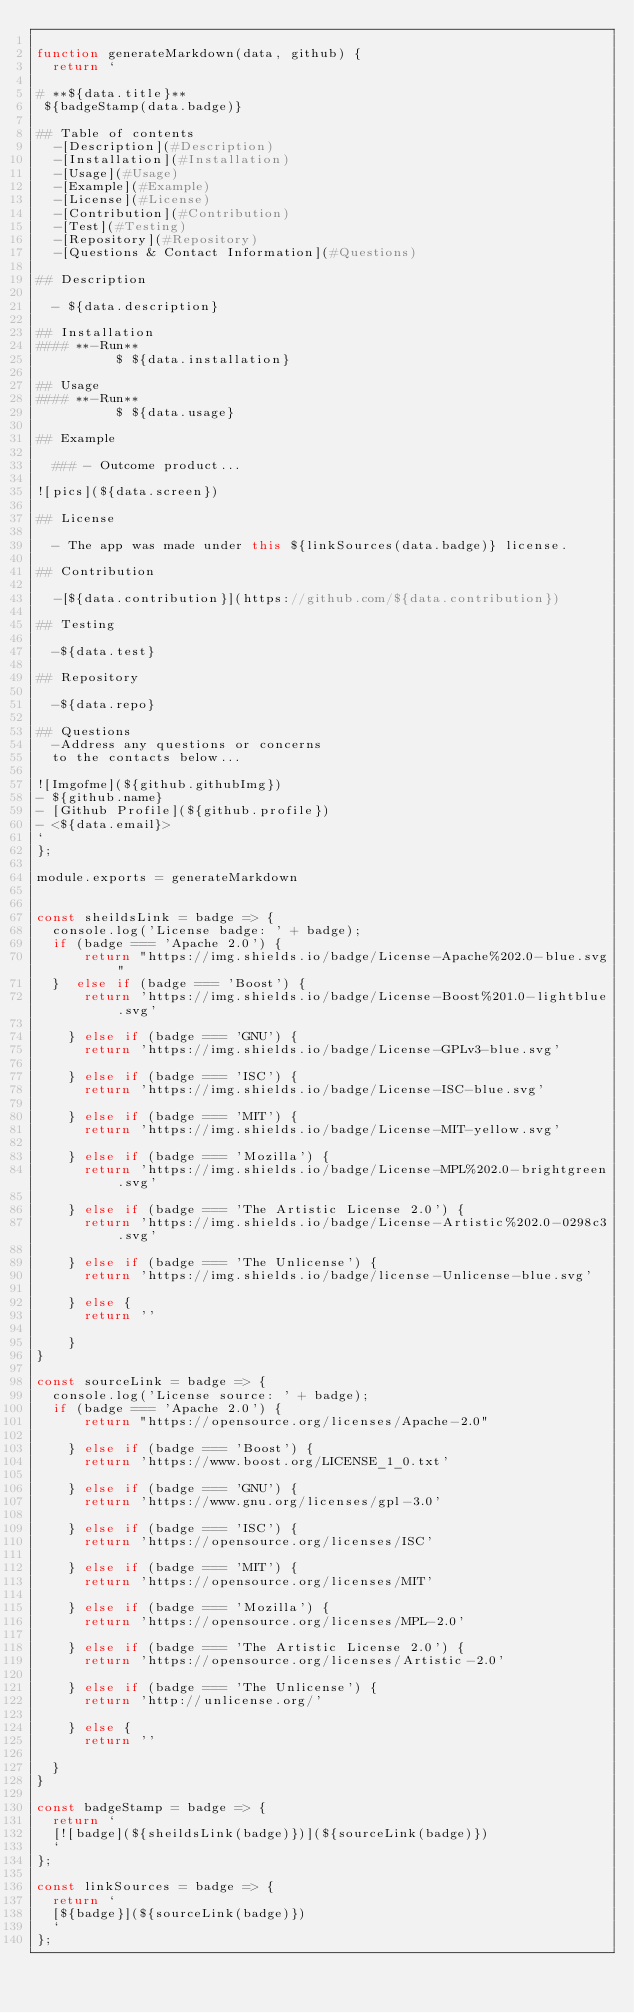Convert code to text. <code><loc_0><loc_0><loc_500><loc_500><_JavaScript_>
function generateMarkdown(data, github) {
  return `

# **${data.title}**
 ${badgeStamp(data.badge)}

## Table of contents
  -[Description](#Description)
  -[Installation](#Installation)
  -[Usage](#Usage)
  -[Example](#Example)
  -[License](#License)
  -[Contribution](#Contribution)
  -[Test](#Testing)
  -[Repository](#Repository)
  -[Questions & Contact Information](#Questions)

## Description

  - ${data.description}

## Installation
#### **-Run**
          $ ${data.installation}
    
## Usage
#### **-Run**
          $ ${data.usage}

## Example 

  ### - Outcome product...

![pics](${data.screen})

## License

  - The app was made under this ${linkSources(data.badge)} license.

## Contribution

  -[${data.contribution}](https://github.com/${data.contribution})

## Testing 
  
  -${data.test}

## Repository

  -${data.repo}

## Questions
  -Address any questions or concerns 
  to the contacts below...
                
![Imgofme](${github.githubImg})
- ${github.name}
- [Github Profile](${github.profile})
- <${data.email}>
`
};

module.exports = generateMarkdown


const sheildsLink = badge => {
  console.log('License badge: ' + badge);
  if (badge === 'Apache 2.0') {
      return "https://img.shields.io/badge/License-Apache%202.0-blue.svg"
  }  else if (badge === 'Boost') {
      return 'https://img.shields.io/badge/License-Boost%201.0-lightblue.svg'
  
    } else if (badge === 'GNU') {
      return 'https://img.shields.io/badge/License-GPLv3-blue.svg'
  
    } else if (badge === 'ISC') {
      return 'https://img.shields.io/badge/License-ISC-blue.svg'
  
    } else if (badge === 'MIT') {
      return 'https://img.shields.io/badge/License-MIT-yellow.svg'
  
    } else if (badge === 'Mozilla') {
      return 'https://img.shields.io/badge/License-MPL%202.0-brightgreen.svg'
  
    } else if (badge === 'The Artistic License 2.0') {
      return 'https://img.shields.io/badge/License-Artistic%202.0-0298c3.svg'
  
    } else if (badge === 'The Unlicense') {
      return 'https://img.shields.io/badge/license-Unlicense-blue.svg'
  
    } else {
      return ''

    }
}

const sourceLink = badge => {
  console.log('License source: ' + badge);
  if (badge === 'Apache 2.0') {
      return "https://opensource.org/licenses/Apache-2.0"
  
    } else if (badge === 'Boost') {
      return 'https://www.boost.org/LICENSE_1_0.txt'
  
    } else if (badge === 'GNU') {
      return 'https://www.gnu.org/licenses/gpl-3.0'
  
    } else if (badge === 'ISC') {
      return 'https://opensource.org/licenses/ISC'
  
    } else if (badge === 'MIT') {
      return 'https://opensource.org/licenses/MIT'
  
    } else if (badge === 'Mozilla') {
      return 'https://opensource.org/licenses/MPL-2.0'
  
    } else if (badge === 'The Artistic License 2.0') {
      return 'https://opensource.org/licenses/Artistic-2.0'
  
    } else if (badge === 'The Unlicense') {
      return 'http://unlicense.org/'
  
    } else {
      return ''
  
  }   
}

const badgeStamp = badge => {
  return `
  [![badge](${sheildsLink(badge)})](${sourceLink(badge)})
  `
};

const linkSources = badge => {
  return `
  [${badge}](${sourceLink(badge)})
  `
};
</code> 